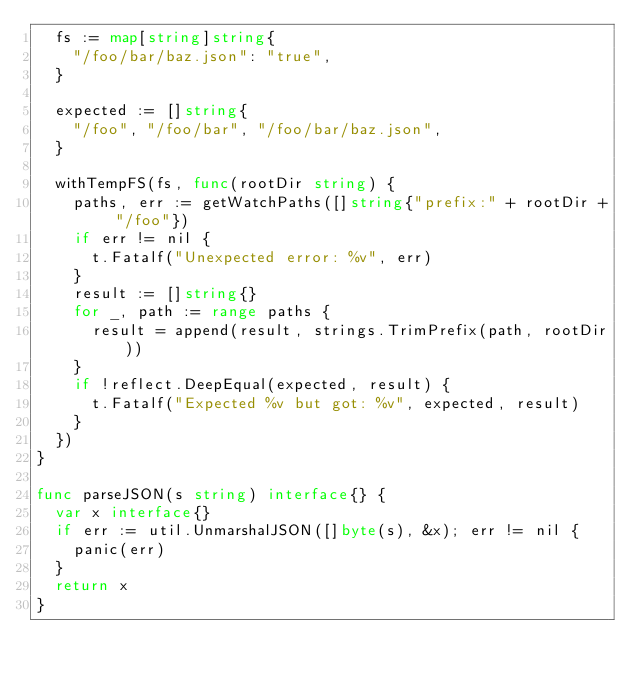<code> <loc_0><loc_0><loc_500><loc_500><_Go_>	fs := map[string]string{
		"/foo/bar/baz.json": "true",
	}

	expected := []string{
		"/foo", "/foo/bar", "/foo/bar/baz.json",
	}

	withTempFS(fs, func(rootDir string) {
		paths, err := getWatchPaths([]string{"prefix:" + rootDir + "/foo"})
		if err != nil {
			t.Fatalf("Unexpected error: %v", err)
		}
		result := []string{}
		for _, path := range paths {
			result = append(result, strings.TrimPrefix(path, rootDir))
		}
		if !reflect.DeepEqual(expected, result) {
			t.Fatalf("Expected %v but got: %v", expected, result)
		}
	})
}

func parseJSON(s string) interface{} {
	var x interface{}
	if err := util.UnmarshalJSON([]byte(s), &x); err != nil {
		panic(err)
	}
	return x
}
</code> 